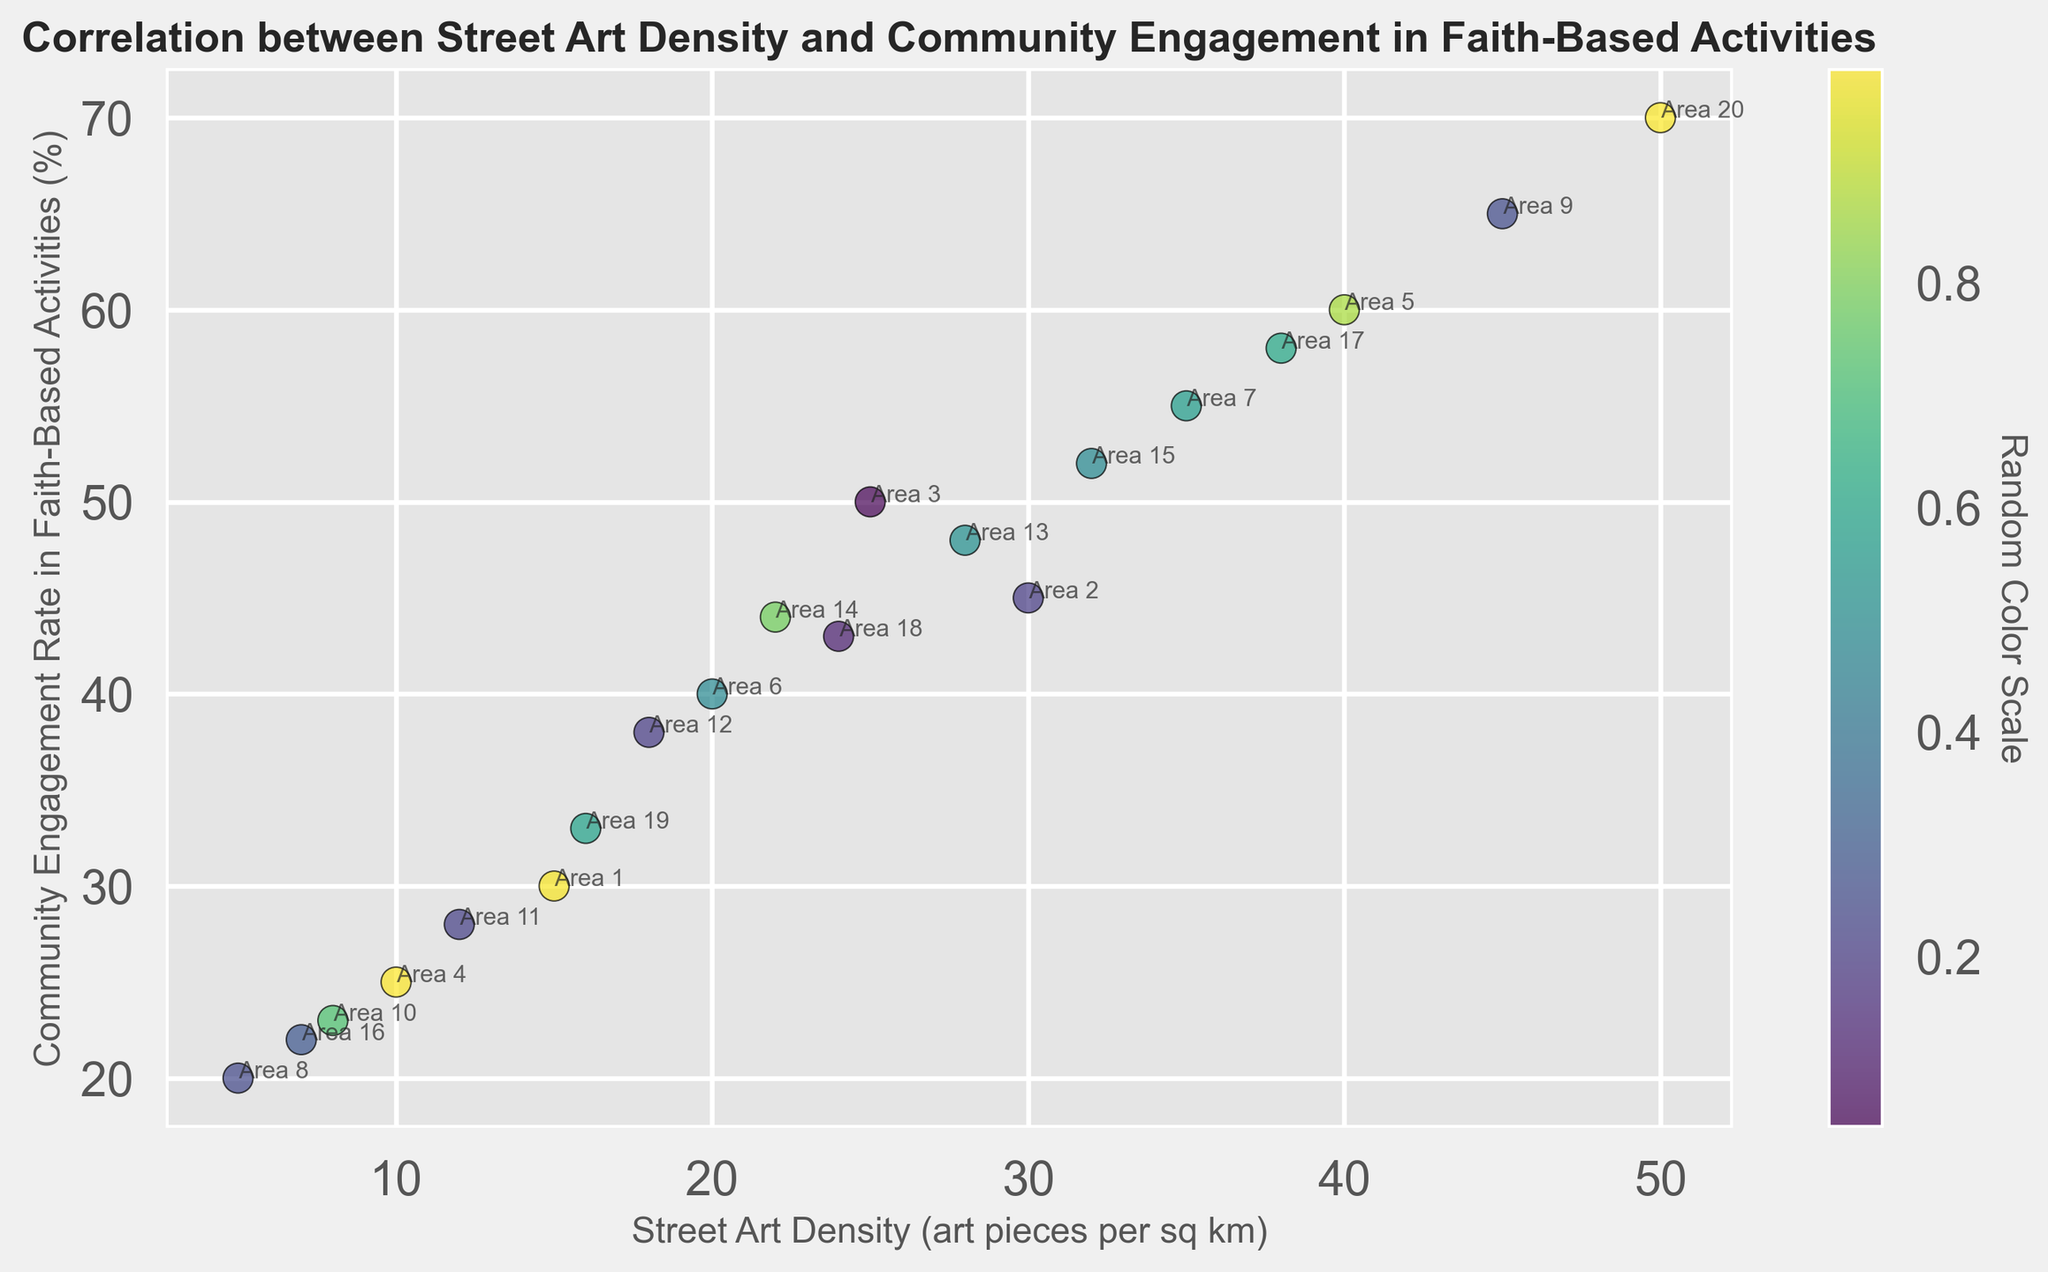What is the relationship between street art density and community engagement in faith-based activities? Observing the scatter plot, as street art density increases, community engagement rates in faith-based activities also generally increase, suggesting a positive correlation.
Answer: Positive correlation Which urban area has the highest street art density and the highest community engagement rate? By looking at the scatter plot, the urban area "Area 20" has the highest street art density (50 art pieces per sq km) and the highest community engagement rate (70%).
Answer: Area 20 Is there an urban area with low street art density but high community engagement rates? The urban areas with lower street art density but not the lowest community engagement rates are "Area 6" with 20 art pieces per sq km and 40% engagement and "Area 14" with 22 art pieces per sq km and 44% engagement. However, these areas do not have extremely low art density or extremely high engagement rates.
Answer: Area 6 and Area 14, but moderately Comparing Area 5 and Area 7, which one has higher community engagement in faith-based activities? From the scatter plot, Area 5 has 40 street art density and 60% community engagement, and Area 7 has 35 street art density and 55% community engagement. Therefore, Area 5 has higher community engagement.
Answer: Area 5 Which urban area has a street art density between 15 and 25 and what is its community engagement rate? By examining the scatter plot, "Area 3" has a street art density of 25 and community engagement rate of 50%.
Answer: Area 3: 50% What is the median community engagement rate among all the urban areas? To find the median, list the community engagement rates in ascending order: 20, 22, 23, 25, 28, 30, 33, 38, 40, 43, 44, 45, 48, 50, 52, 55, 58, 60, 65, 70. The median value (10th and 11th values of ordered list) is the average of 43 and 44, which is (43 + 44) / 2 = 43.5.
Answer: 43.5 Which urban areas fall within the highest color intensity range on the color scale? The color intensity is randomly generated for visual purposes. In general, visually brighter or most intense colors can be observed on the far right of the scatter plot, predominantly for "Area 9" and "Area 20".
Answer: Area 9 and Area 20 What is the difference in community engagement rates between the urban area with the highest and the lowest street art density? The highest street art density is in Area 20 (50 art pieces per sq km, 70% engagement). The lowest street art density is in Area 8 (5 art pieces per sq km, 20% engagement). The difference is 70% - 20% = 50%.
Answer: 50% Is there any outlier in terms of street art density or community engagement rate? From the scatter plot, "Area 20" with a street art density of 50 is much higher than others. Similarly, its community engagement rate of 70% is also much higher, making it an outlier in both respects.
Answer: Area 20 